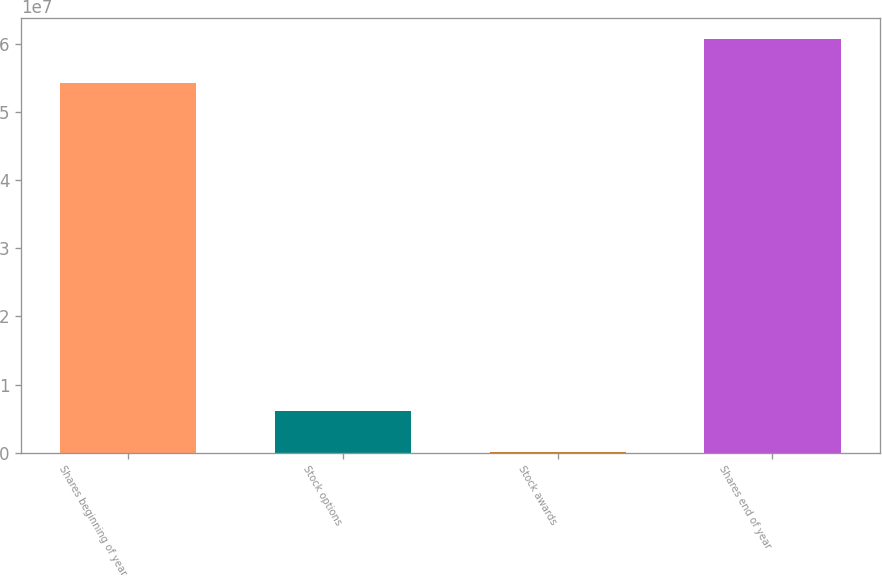<chart> <loc_0><loc_0><loc_500><loc_500><bar_chart><fcel>Shares beginning of year<fcel>Stock options<fcel>Stock awards<fcel>Shares end of year<nl><fcel>5.43727e+07<fcel>6.09113e+06<fcel>14291<fcel>6.07827e+07<nl></chart> 